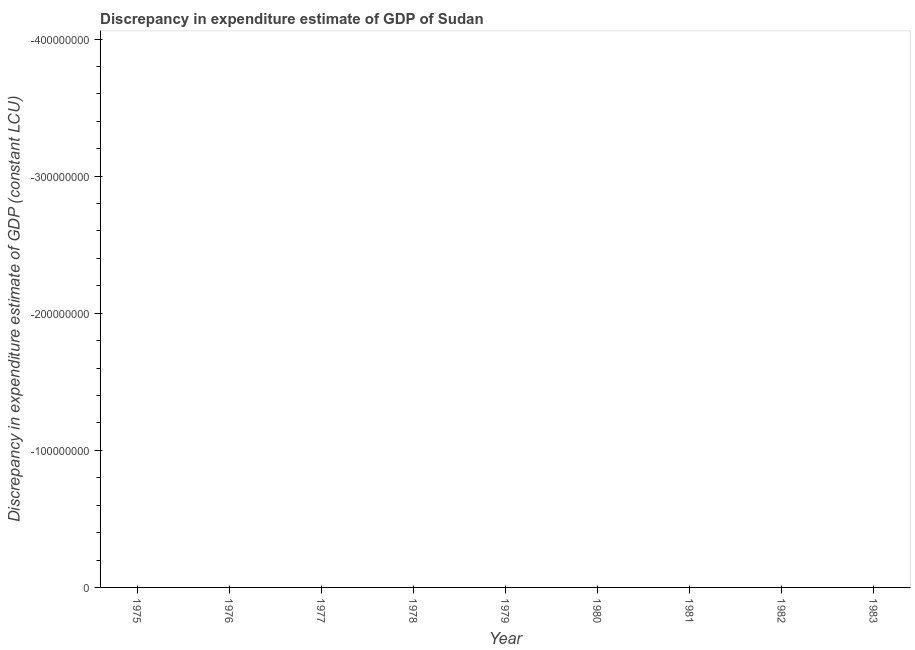What is the discrepancy in expenditure estimate of gdp in 1975?
Make the answer very short. 0. Across all years, what is the minimum discrepancy in expenditure estimate of gdp?
Offer a very short reply. 0. What is the sum of the discrepancy in expenditure estimate of gdp?
Offer a terse response. 0. How many lines are there?
Make the answer very short. 0. How many years are there in the graph?
Give a very brief answer. 9. Are the values on the major ticks of Y-axis written in scientific E-notation?
Keep it short and to the point. No. Does the graph contain any zero values?
Offer a terse response. Yes. What is the title of the graph?
Your answer should be very brief. Discrepancy in expenditure estimate of GDP of Sudan. What is the label or title of the X-axis?
Ensure brevity in your answer.  Year. What is the label or title of the Y-axis?
Offer a very short reply. Discrepancy in expenditure estimate of GDP (constant LCU). What is the Discrepancy in expenditure estimate of GDP (constant LCU) of 1979?
Give a very brief answer. 0. What is the Discrepancy in expenditure estimate of GDP (constant LCU) in 1981?
Give a very brief answer. 0. What is the Discrepancy in expenditure estimate of GDP (constant LCU) of 1982?
Give a very brief answer. 0. 